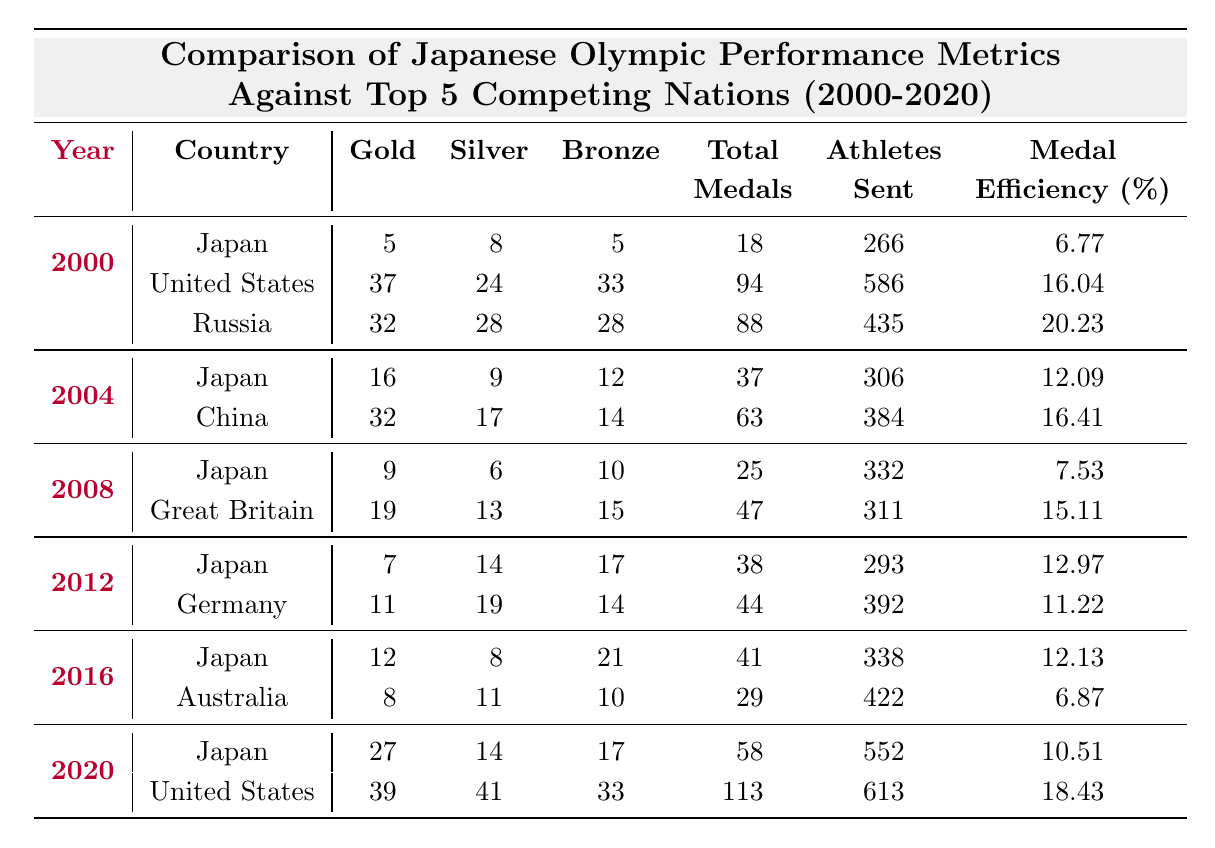What was Japan's total medal count in the 2004 Olympics? According to the table, Japan's total medal count in the 2004 Olympics is listed as 37.
Answer: 37 Which country won the most gold medals in 2008? The table shows that Great Britain won the most gold medals in 2008, with a total of 19.
Answer: Great Britain What is the average number of gold medals won by Japan from 2000 to 2020? Japan won 5 (2000) + 16 (2004) + 9 (2008) + 7 (2012) + 12 (2016) + 27 (2020) = 76 gold medals over 6 events. The average is 76 / 6 = 12.67.
Answer: 12.67 Did Japan win more total medals or gold medals in 2020? In 2020, Japan won a total of 58 medals and 27 gold medals. Since 58 is greater than 27, Japan won more total medals than gold medals in 2020.
Answer: Yes What was the medal efficiency of Russia in the year 2000? The table indicates that Russia's medal efficiency in 2000 was 20.23%.
Answer: 20.23% What was the difference in total medal efficiency between Japan in 2012 and Germany in the same year? Japan had a medal efficiency of 12.97% and Germany had 11.22%. The difference is 12.97 - 11.22 = 1.75%.
Answer: 1.75% Which year did Japan have its highest total medal count? Upon examining the table, Japan had its highest total medal count in 2020 with 58 medals.
Answer: 2020 How many more athletes did the United States send in 2020 compared to Japan? The United States sent 613 athletes and Japan sent 552 athletes in 2020. The difference is 613 - 552 = 61 athletes.
Answer: 61 In which Olympic year did Japan achieve the lowest medal efficiency? The table shows Japan's lowest medal efficiency was in 2008 at 7.53%.
Answer: 2008 If we consider the total number of medals won by Japan in 2016 and the United States in 2020, which country had a higher total? Japan won 41 medals in 2016, while the United States won 113 in 2020. Since 113 > 41, the United States had a higher total.
Answer: United States 